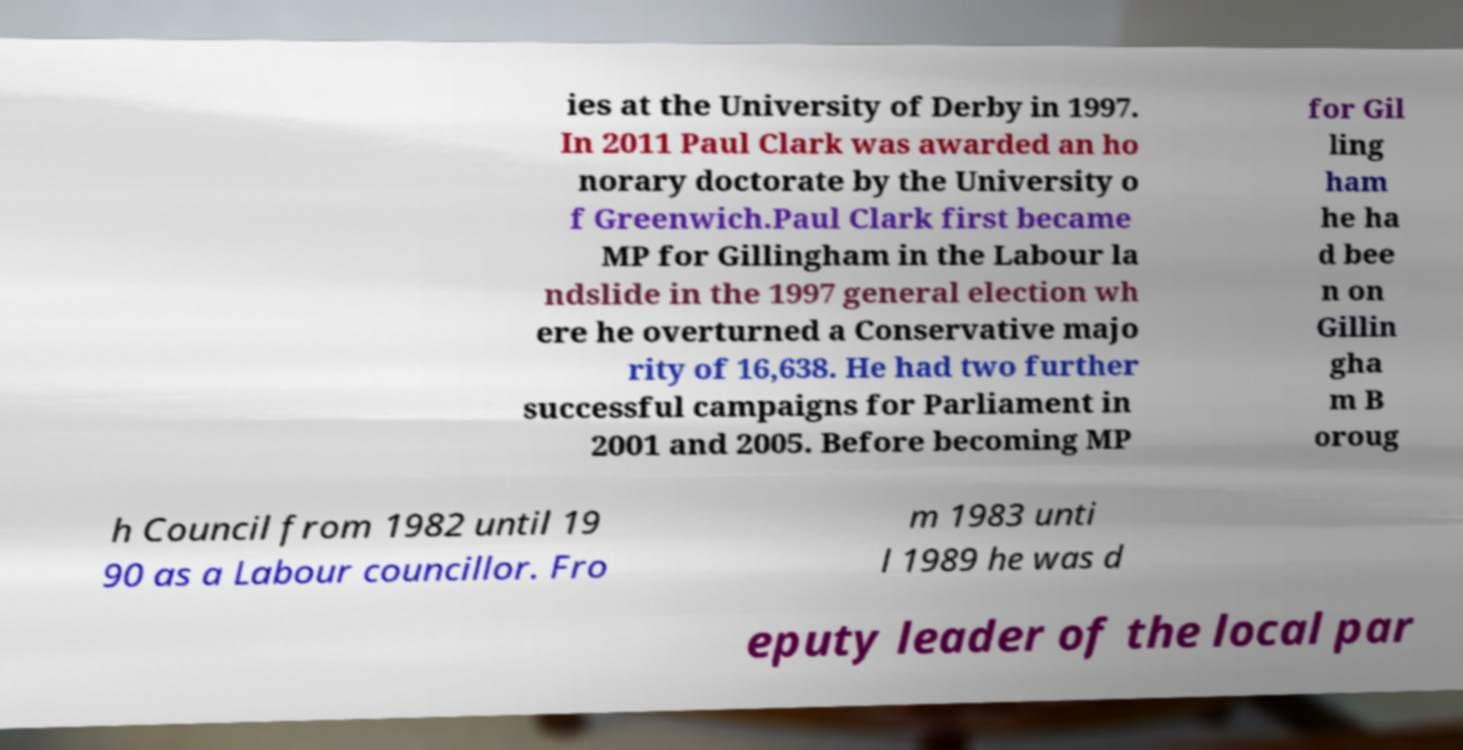What messages or text are displayed in this image? I need them in a readable, typed format. ies at the University of Derby in 1997. In 2011 Paul Clark was awarded an ho norary doctorate by the University o f Greenwich.Paul Clark first became MP for Gillingham in the Labour la ndslide in the 1997 general election wh ere he overturned a Conservative majo rity of 16,638. He had two further successful campaigns for Parliament in 2001 and 2005. Before becoming MP for Gil ling ham he ha d bee n on Gillin gha m B oroug h Council from 1982 until 19 90 as a Labour councillor. Fro m 1983 unti l 1989 he was d eputy leader of the local par 